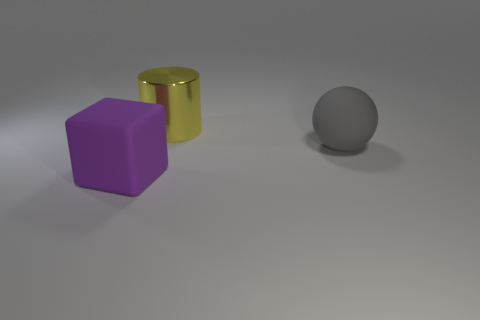Considering the positions of the objects, can we infer anything about the source of lighting in the scene? Yes, by observing the shadows and highlights on the objects, it suggests that the light source is located to the top left of the scene. The shadows are cast towards the bottom right, longer for the cylinder and shorter for the cube and sphere, indicating the angle and direction of the light.  Could you explain how the shadows help determine the relative positions of the objects? Certainly. The length and direction of a shadow can reveal an object's location relative to the light source and other objects. Here, the long shadow of the cylinder suggests it is taller or closer to the light, while the shorter shadows of the cube and sphere indicate they are shorter or further from the light. The shadows converge, implying that the objects are arranged in a triangular formation with regards to the perspective of the light. 